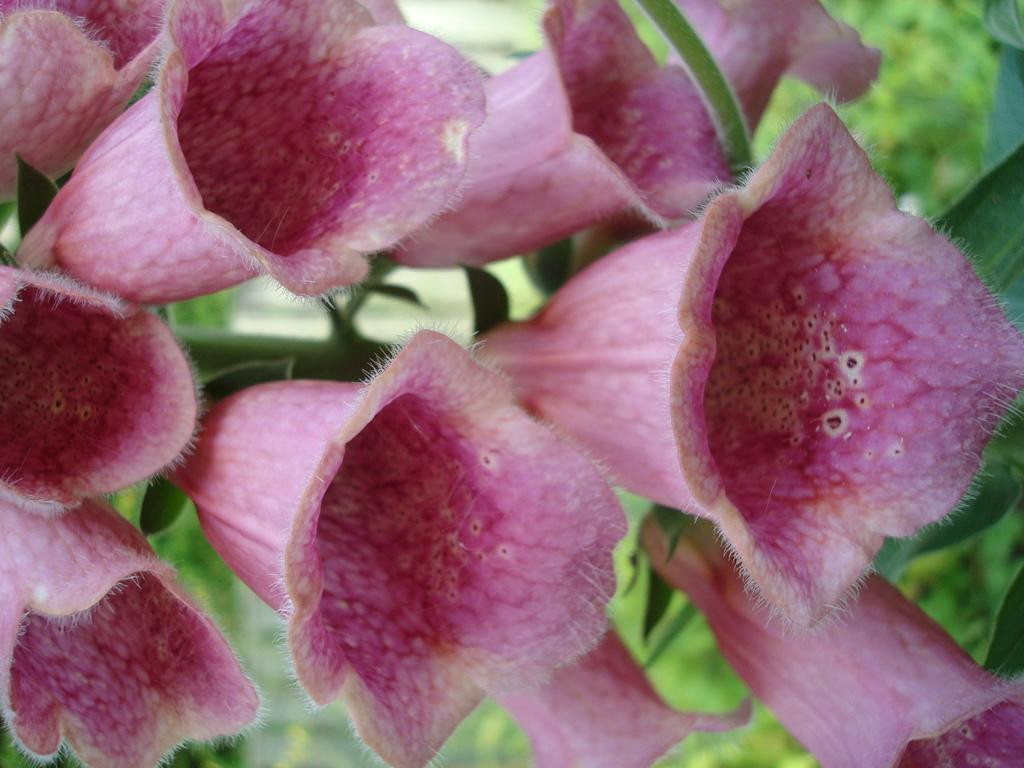What color are the flowers in the image? The flowers in the image are pink. What can be seen in the background of the image? There are trees in green color in the background of the image. What type of crayon is being used to draw the flowers in the image? There is no crayon present in the image; it is a photograph of real flowers. How does the hearing of the flowers in the image function? Flowers do not have the ability to hear, as they are plants and not living beings with auditory systems. 